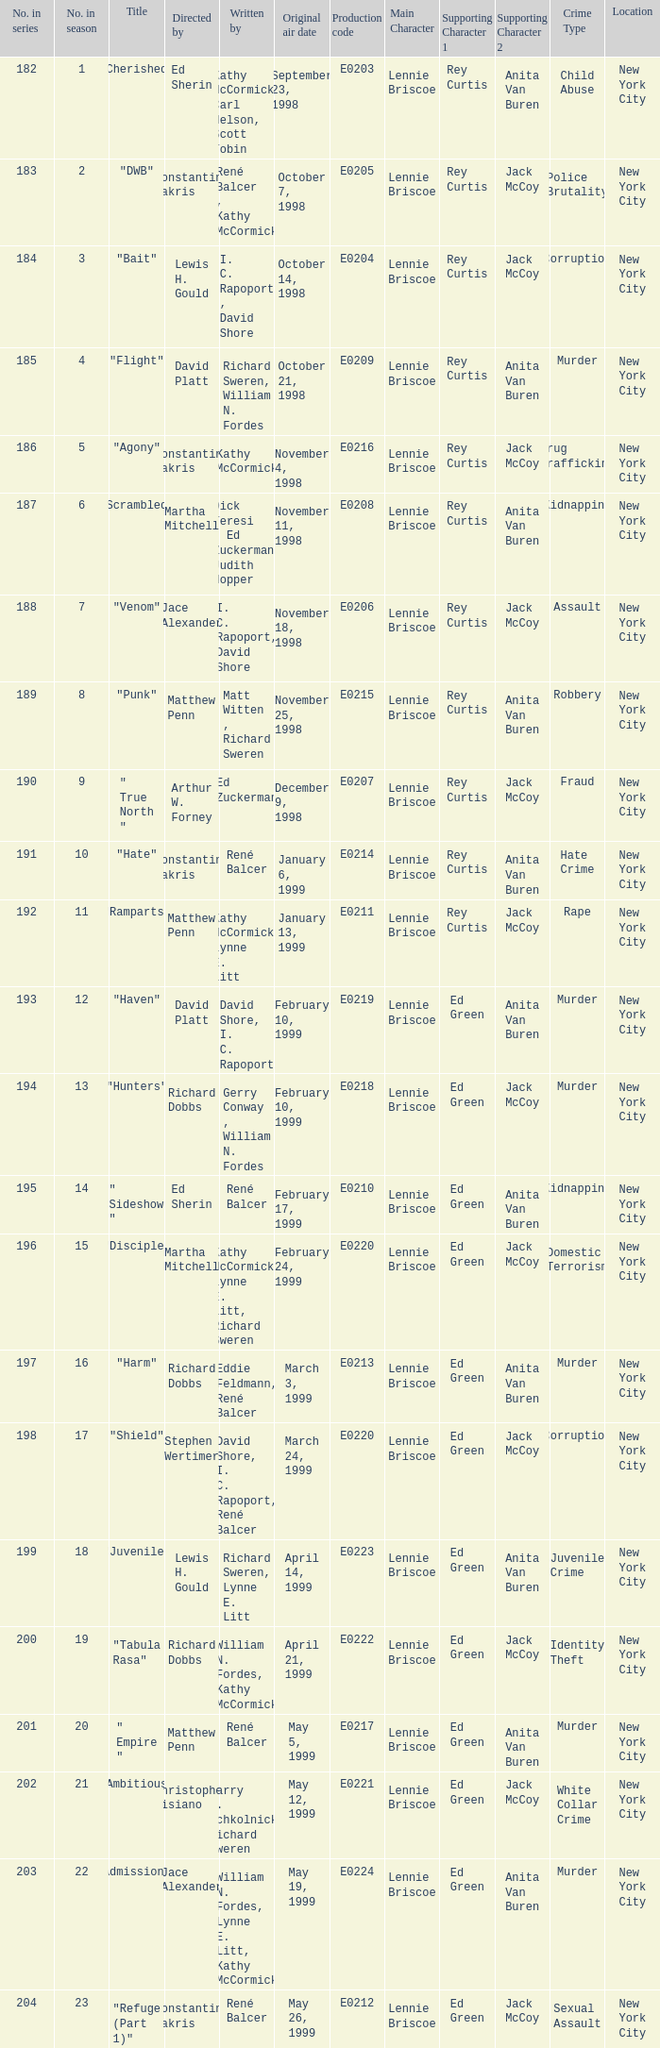What is the season number of the episode written by Matt Witten , Richard Sweren? 8.0. 